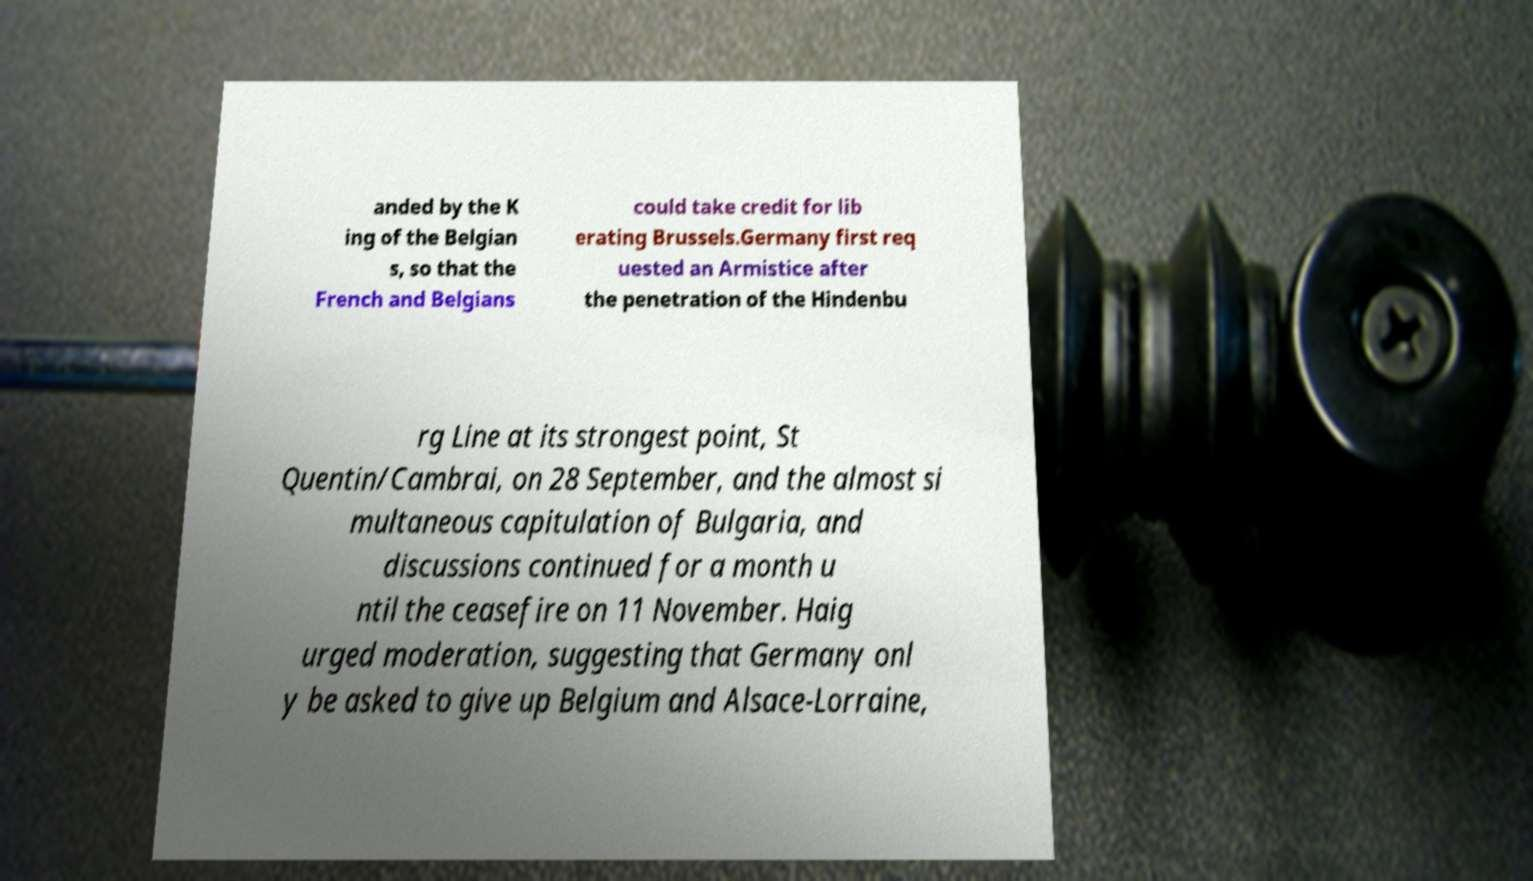Could you extract and type out the text from this image? anded by the K ing of the Belgian s, so that the French and Belgians could take credit for lib erating Brussels.Germany first req uested an Armistice after the penetration of the Hindenbu rg Line at its strongest point, St Quentin/Cambrai, on 28 September, and the almost si multaneous capitulation of Bulgaria, and discussions continued for a month u ntil the ceasefire on 11 November. Haig urged moderation, suggesting that Germany onl y be asked to give up Belgium and Alsace-Lorraine, 